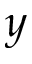Convert formula to latex. <formula><loc_0><loc_0><loc_500><loc_500>y</formula> 